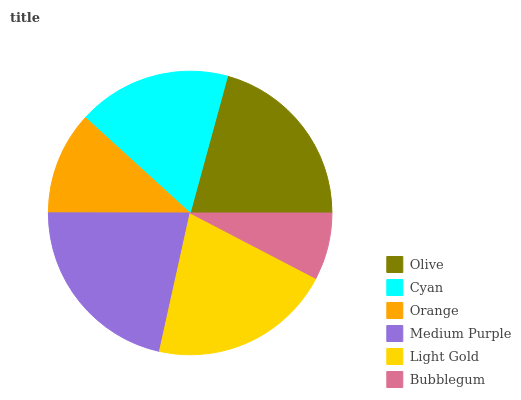Is Bubblegum the minimum?
Answer yes or no. Yes. Is Medium Purple the maximum?
Answer yes or no. Yes. Is Cyan the minimum?
Answer yes or no. No. Is Cyan the maximum?
Answer yes or no. No. Is Olive greater than Cyan?
Answer yes or no. Yes. Is Cyan less than Olive?
Answer yes or no. Yes. Is Cyan greater than Olive?
Answer yes or no. No. Is Olive less than Cyan?
Answer yes or no. No. Is Olive the high median?
Answer yes or no. Yes. Is Cyan the low median?
Answer yes or no. Yes. Is Orange the high median?
Answer yes or no. No. Is Medium Purple the low median?
Answer yes or no. No. 